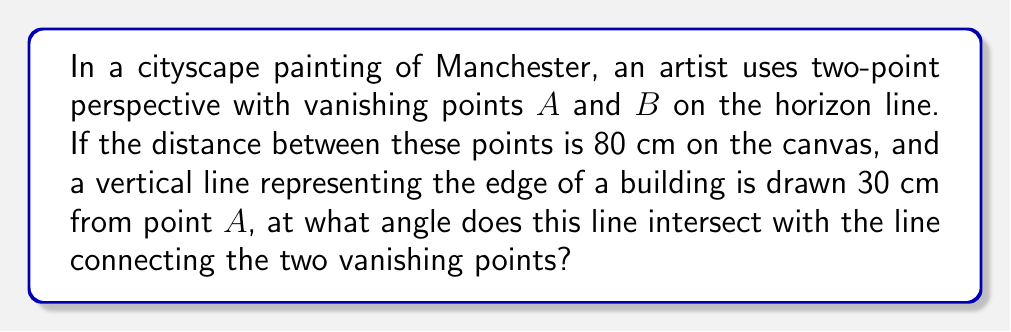Provide a solution to this math problem. Let's approach this step-by-step:

1) First, let's visualize the problem:

   [asy]
   unitsize(1cm);
   pair A = (0,0), B = (8,0), C = (3,3);
   draw(A--B, arrow=Arrow(TeXHead));
   draw(A--C, arrow=Arrow(TeXHead));
   draw(B--C, arrow=Arrow(TeXHead));
   label("A", A, SW);
   label("B", B, SE);
   label("C", C, N);
   label("80 cm", (4,0), S);
   label("30 cm", (1.5,0), N);
   [/asy]

2) We can treat this as a right-angled triangle problem. The line connecting the vanishing points forms the base of the triangle, and the vertical building edge forms one side.

3) We know:
   - The base of the triangle (distance between vanishing points) = 80 cm
   - The distance from point A to the vertical line = 30 cm

4) Let's call the angle we're looking for $\theta$. We can find this using the tangent function:

   $$\tan(\theta) = \frac{\text{opposite}}{\text{adjacent}} = \frac{30}{80-30} = \frac{30}{50} = \frac{3}{5}$$

5) To find $\theta$, we need to take the inverse tangent (arctangent):

   $$\theta = \arctan(\frac{3}{5})$$

6) Using a calculator or mathematical tables, we can find:

   $$\theta \approx 30.96^\circ$$
Answer: $30.96^\circ$ 